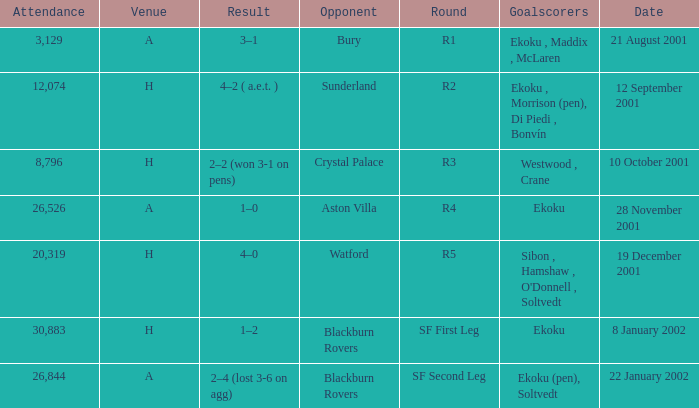Which result has sunderland as opponent? 4–2 ( a.e.t. ). 